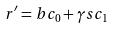<formula> <loc_0><loc_0><loc_500><loc_500>r ^ { \prime } = b c _ { 0 } + \gamma s c _ { 1 }</formula> 